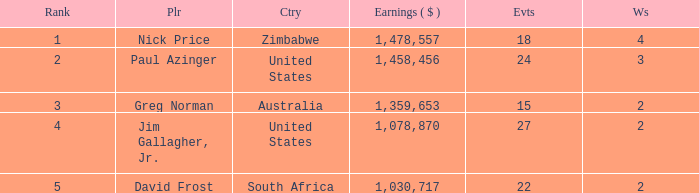How many events have earnings less than 1,030,717? 0.0. 